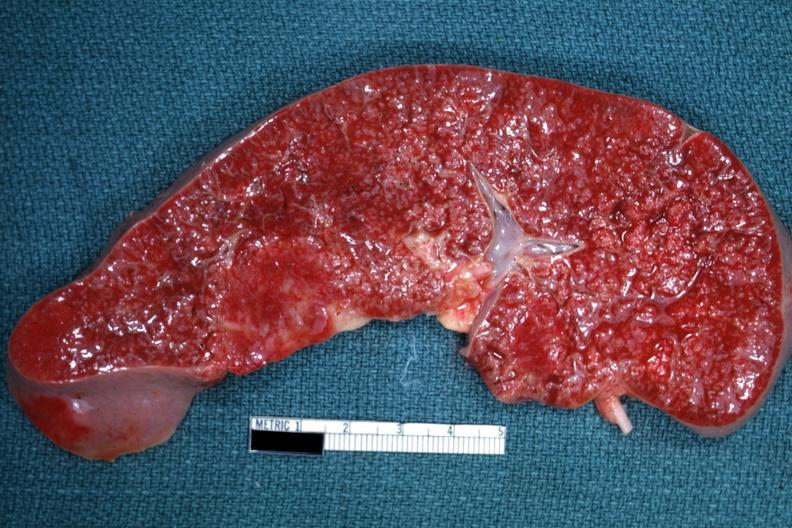s optic nerve present?
Answer the question using a single word or phrase. No 